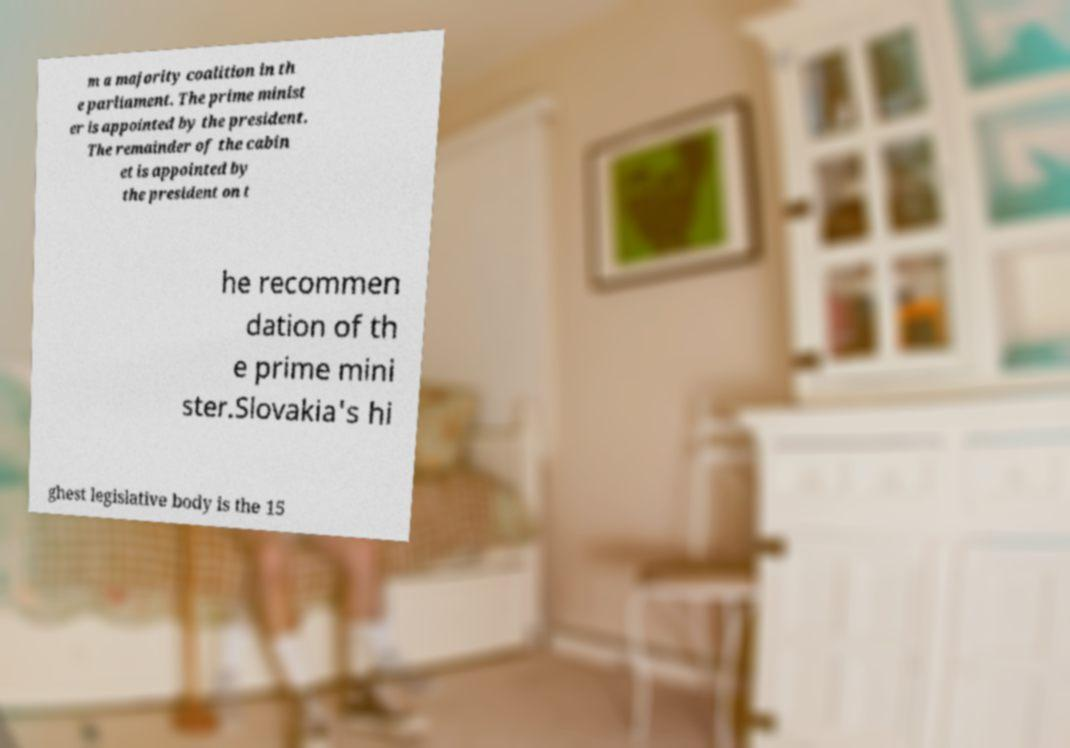For documentation purposes, I need the text within this image transcribed. Could you provide that? m a majority coalition in th e parliament. The prime minist er is appointed by the president. The remainder of the cabin et is appointed by the president on t he recommen dation of th e prime mini ster.Slovakia's hi ghest legislative body is the 15 